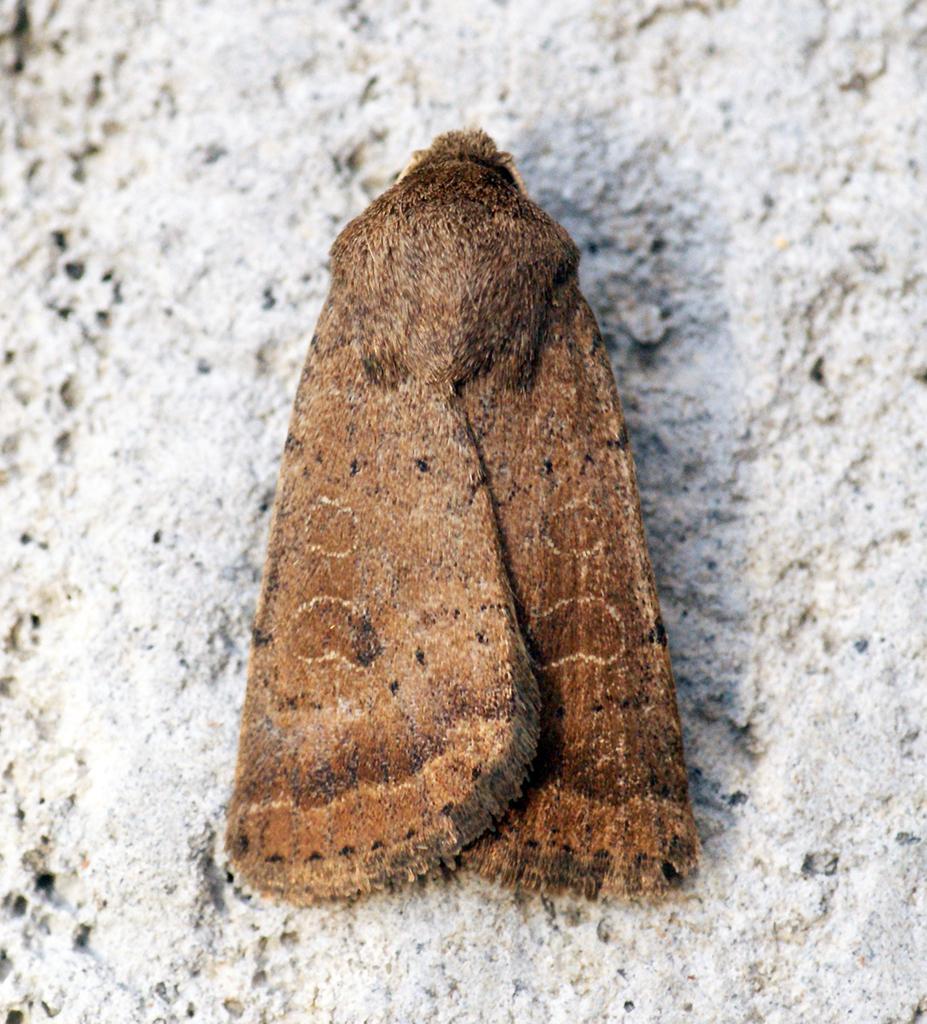Can you describe this image briefly? In this image I can see an insect is on the white color surface. The insect is in brown and black color. 